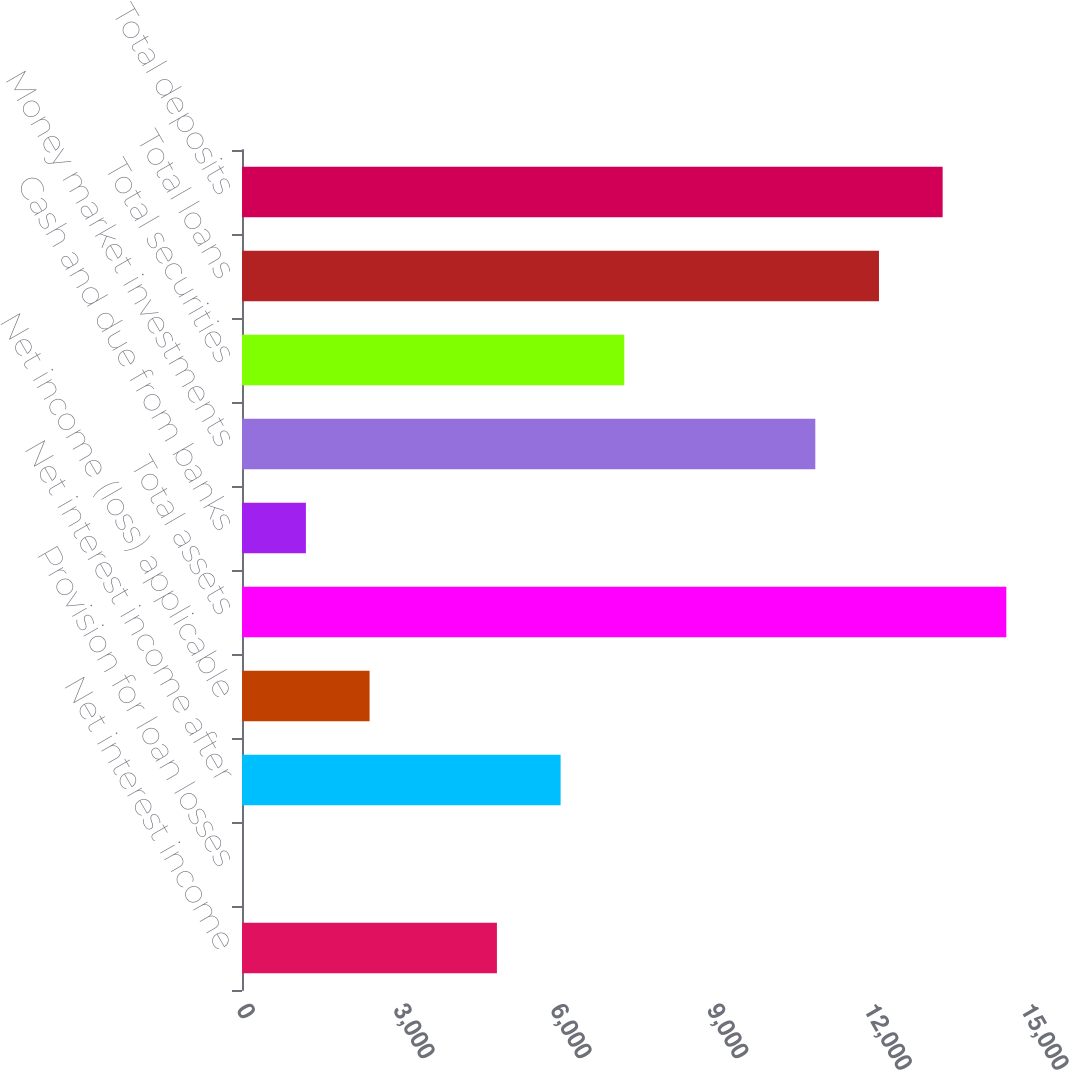Convert chart to OTSL. <chart><loc_0><loc_0><loc_500><loc_500><bar_chart><fcel>Net interest income<fcel>Provision for loan losses<fcel>Net interest income after<fcel>Net income (loss) applicable<fcel>Total assets<fcel>Cash and due from banks<fcel>Money market investments<fcel>Total securities<fcel>Total loans<fcel>Total deposits<nl><fcel>4877.44<fcel>4.4<fcel>6095.7<fcel>2440.92<fcel>14623.5<fcel>1222.66<fcel>10968.7<fcel>7313.96<fcel>12187<fcel>13405.3<nl></chart> 